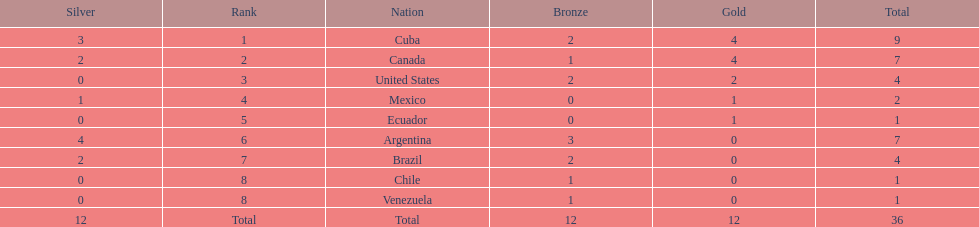How many total medals did argentina win? 7. 